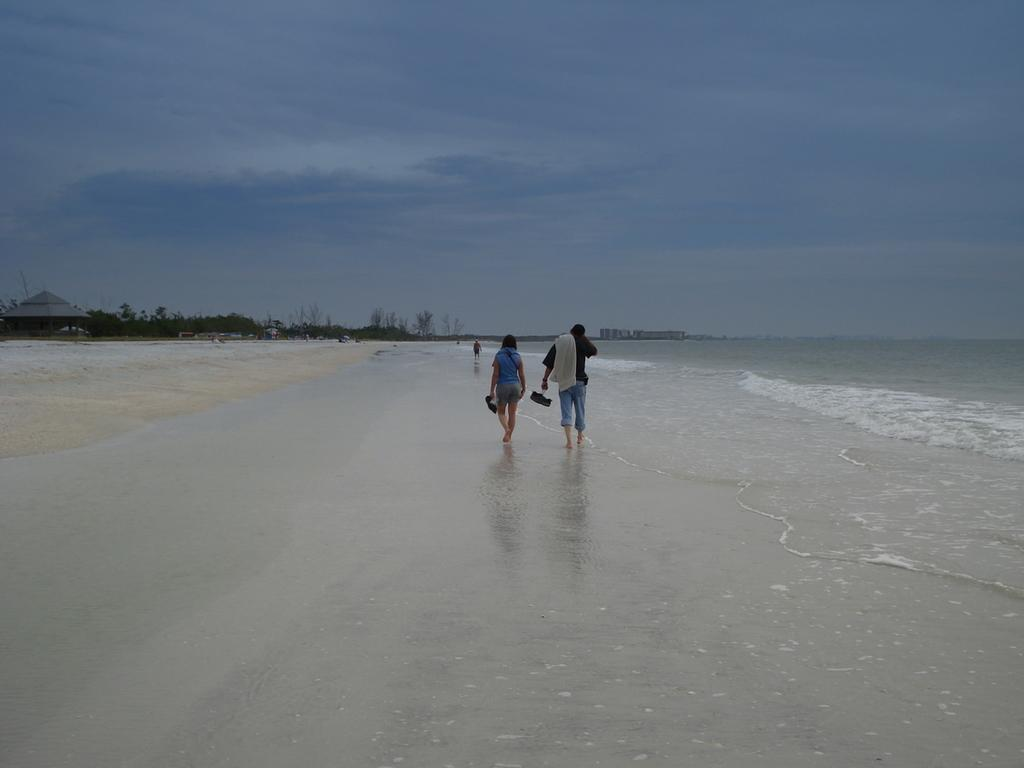Who can be seen in the image? There is a man and a woman in the image. What are the man and woman doing in the image? The man and woman are walking along the beach. What can be seen on the right side of the image? There is an ocean on the right side of the image. What is present on the left side of the image? There are trees on the left side of the image. What is the condition of the sky in the image? The sky is clear in the image. What type of drum can be seen being played by a wren in the image? There is no drum or wren present in the image. How does the cow interact with the trees on the left side of the image? There is no cow present in the image, so it cannot interact with the trees. 